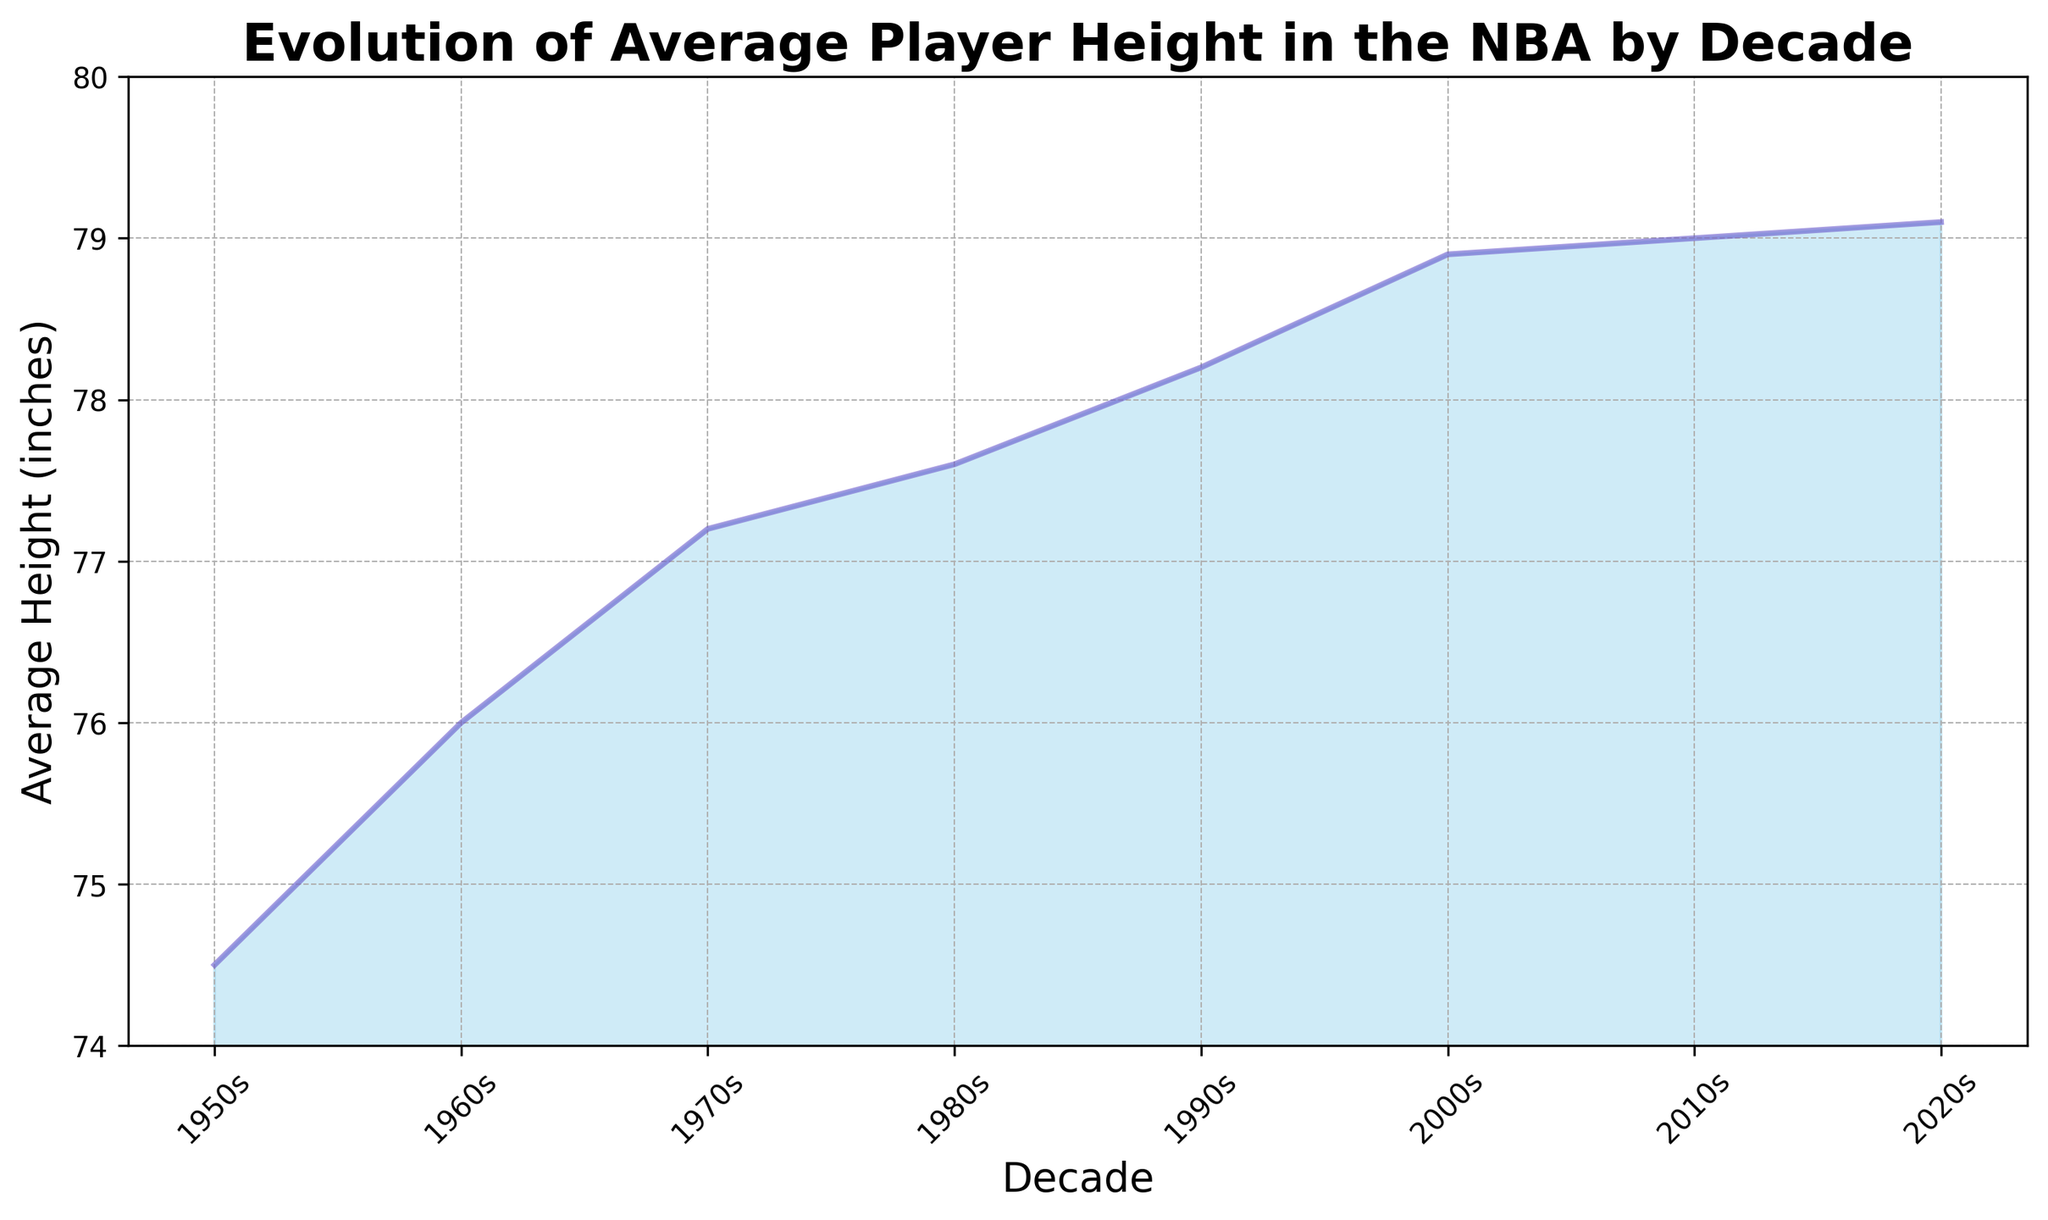Which decade saw the greatest increase in average player height compared to the previous decade? To determine the decade with the greatest increase, we need to compare the differences in average height from one decade to the next. The largest height increase can be observed from the 1990s to the 2000s, with a difference of 0.7 inches (78.9 - 78.2).
Answer: 2000s What is the overall increase in average player height from the 1950s to the 2020s? Subtract the average height of the 1950s from the average height of the 2020s: 79.1 - 74.5 = 4.6 inches.
Answer: 4.6 inches Which decades show a relatively stable average height with minimal increase? By examining the chart, we can see that the increase in height from the 2000s to the 2010s (0.1 inches) and from the 2010s to the 2020s (0.1 inches) is minimal, indicating relative stability.
Answer: 2000s to 2020s How does the player height in the 1970s compare with the 1950s? To compare, subtract the average height of the 1950s from the 1970s: 77.2 - 74.5 = 2.7 inches.
Answer: 2.7 inches taller In which decade did the average player height surpass 78 inches for the first time? By looking at the chart, we can see that the average height first surpasses 78 inches in the 1990s.
Answer: 1990s Is there a period where the growth rate in player height appears to slow down or plateau? The chart shows a significant slow down in growth from the 2000s onwards, with only a 0.1 inches increase from the 2000s to 2010s and again from the 2010s to 2020s.
Answer: Yes, from 2000s onwards Did the average height in the 2020s exceed 79 inches? Observing the data point for the 2020s shows the average height is 79.1 inches, which is just over 79 inches.
Answer: Yes How much did the average height increase from the 1960s to the 1980s? Subtract the average height of the 1960s from the average height of the 1980s: 77.6 - 76.0 = 1.6 inches.
Answer: 1.6 inches 